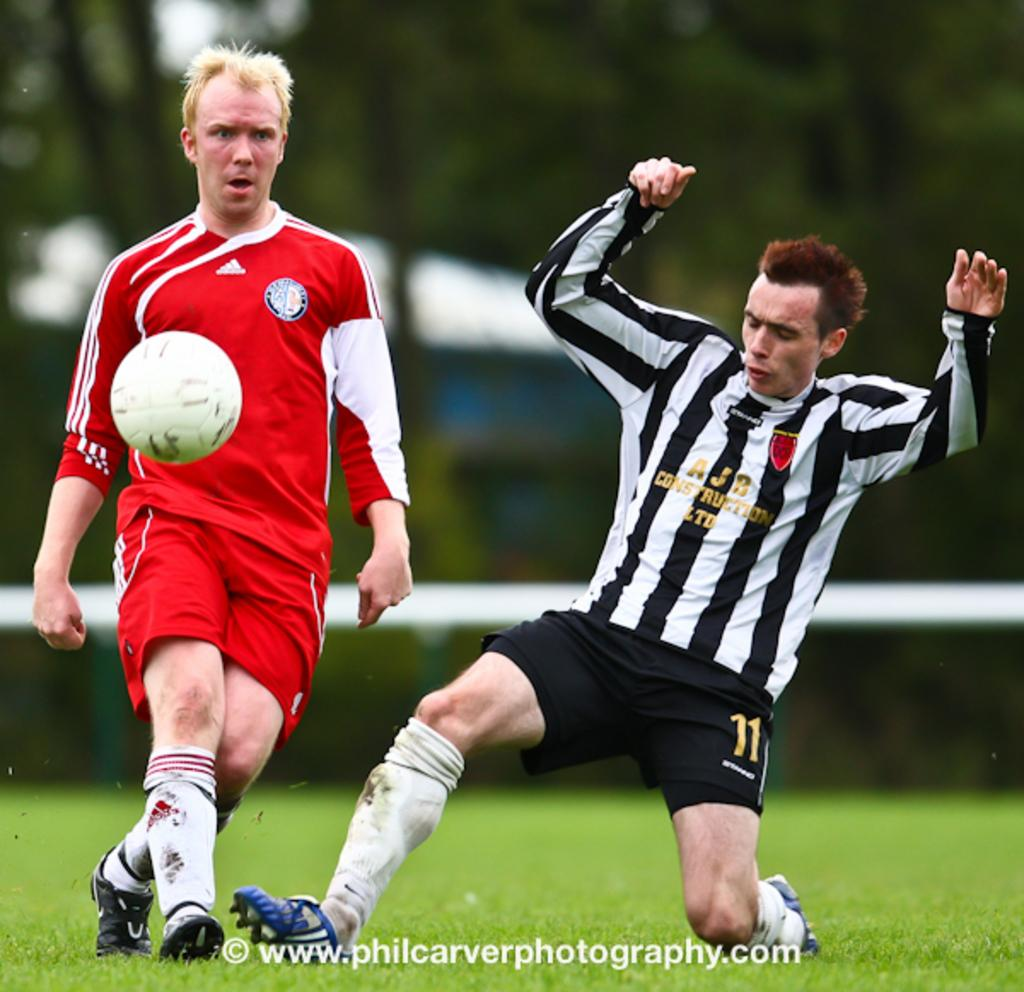Provide a one-sentence caption for the provided image. A footballer in a black and white striped to sponsered by AJB Construction tackles and opponent wearing red. 